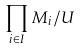<formula> <loc_0><loc_0><loc_500><loc_500>\prod _ { i \in I } M _ { i } / U</formula> 